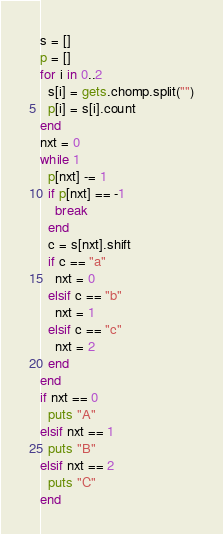Convert code to text. <code><loc_0><loc_0><loc_500><loc_500><_Ruby_>s = []
p = []
for i in 0..2
  s[i] = gets.chomp.split("")
  p[i] = s[i].count
end
nxt = 0
while 1
  p[nxt] -= 1
  if p[nxt] == -1
    break
  end
  c = s[nxt].shift
  if c == "a"
    nxt = 0
  elsif c == "b"
    nxt = 1
  elsif c == "c"
    nxt = 2
  end
end
if nxt == 0
  puts "A"
elsif nxt == 1
  puts "B"
elsif nxt == 2
  puts "C"
end</code> 